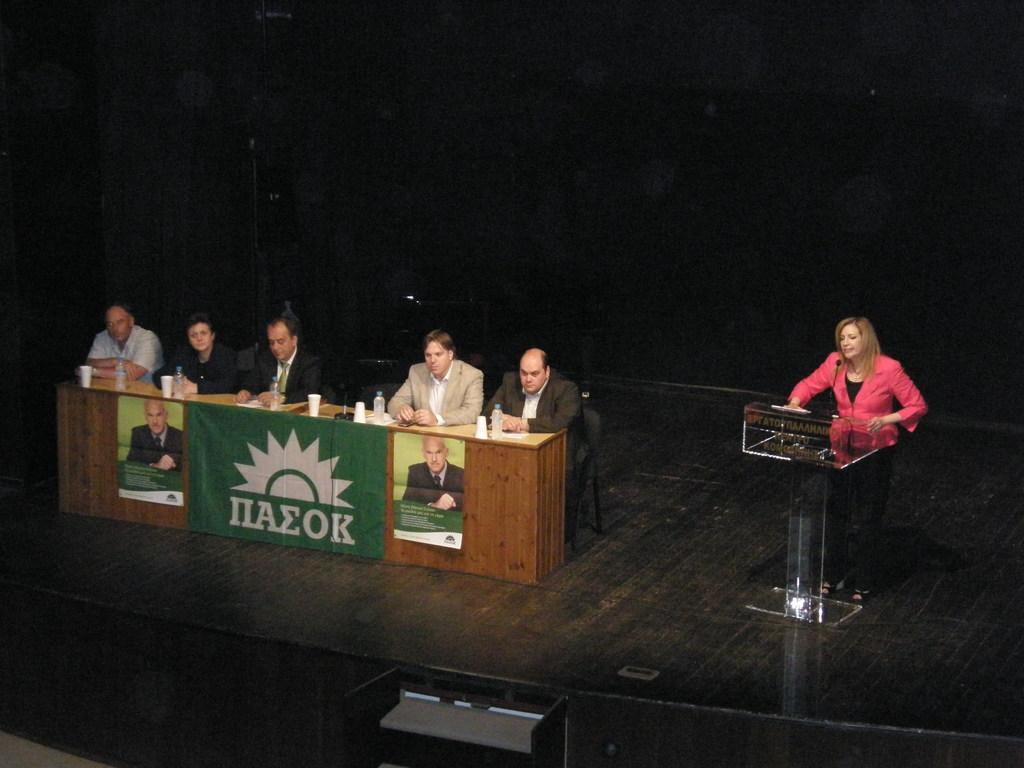Describe this image in one or two sentences. This picture shows that there are members sitting in front of the table in their chairs. On the table there are glasses and water bottles. There are both men and women in these five members. There is another woman standing near the podium and talking in front of a mic on the stage. 